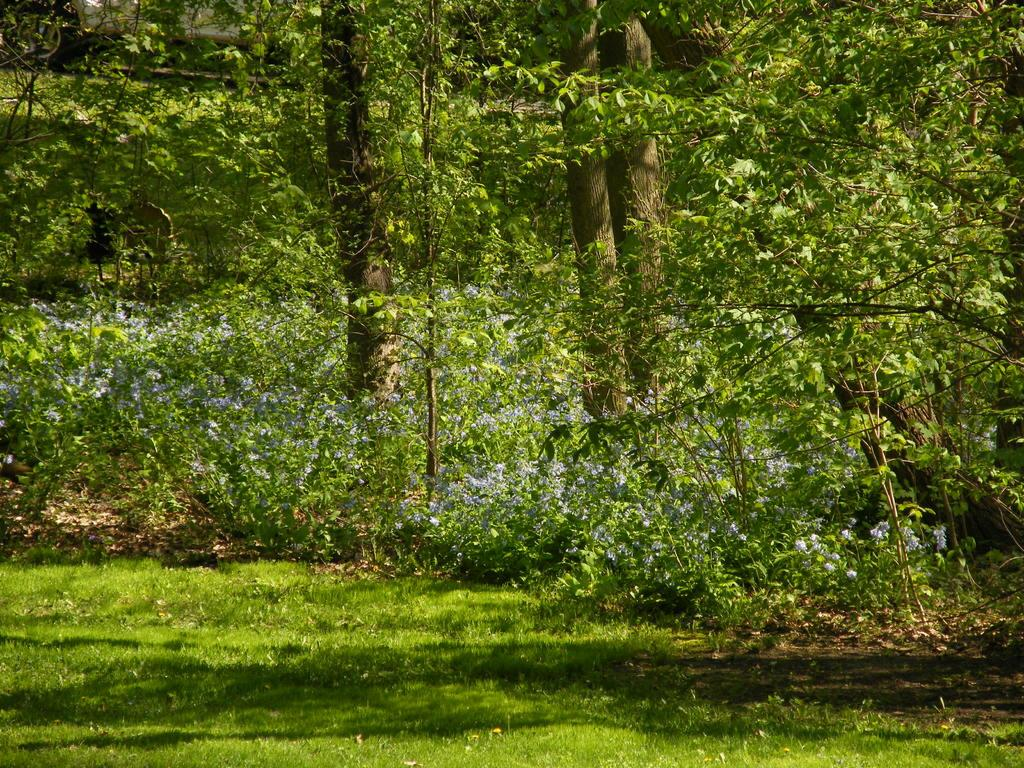What type of vegetation can be seen in the image? There are trees in the image. What is covering the ground in the image? There is grass on the ground in the image. What type of payment is being made in the image? There is no payment being made in the image; it features trees and grass. What type of destruction is visible in the image? There is no destruction visible in the image; it features trees and grass. 